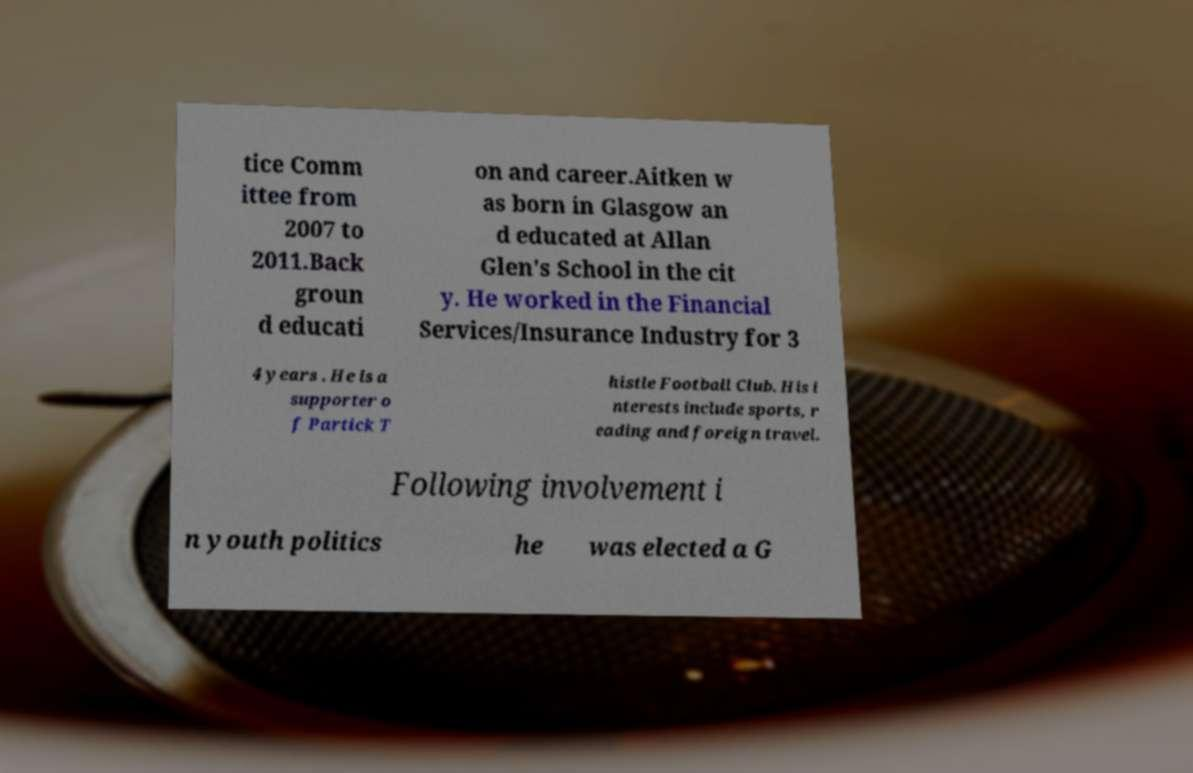Can you read and provide the text displayed in the image?This photo seems to have some interesting text. Can you extract and type it out for me? tice Comm ittee from 2007 to 2011.Back groun d educati on and career.Aitken w as born in Glasgow an d educated at Allan Glen's School in the cit y. He worked in the Financial Services/Insurance Industry for 3 4 years . He is a supporter o f Partick T histle Football Club. His i nterests include sports, r eading and foreign travel. Following involvement i n youth politics he was elected a G 